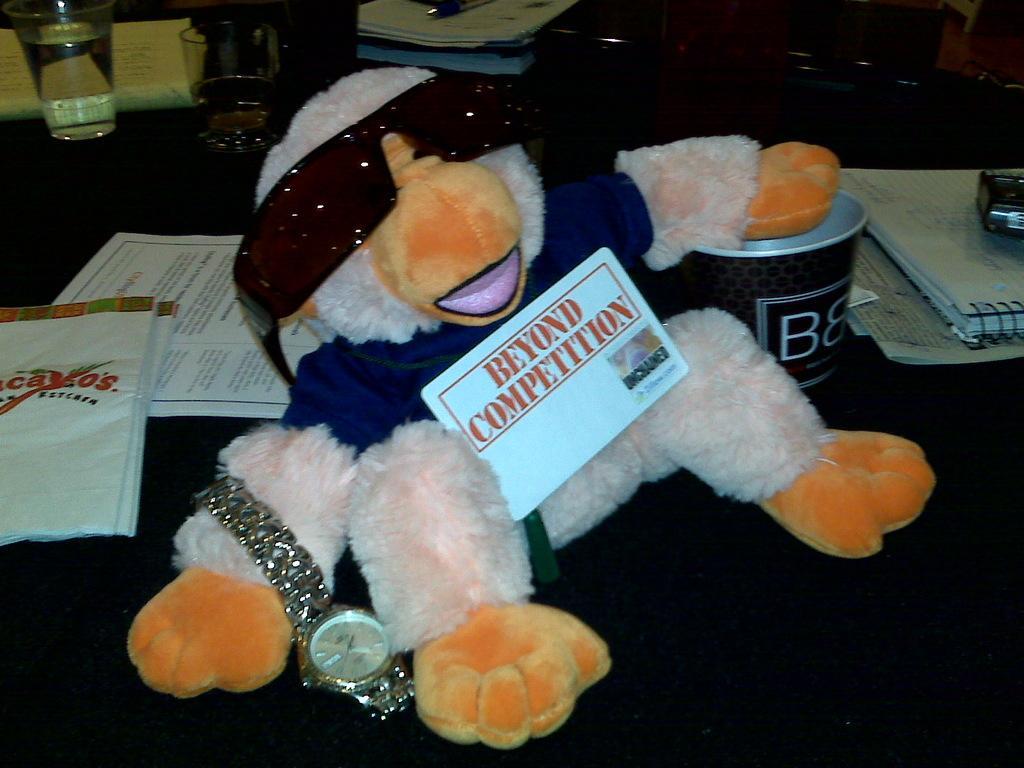Can you describe this image briefly? In this image, there is a toy wearing sunglasses and watch. There is a book and cup on the right side of the image. There are glasses in the top left of the image. There are some papers on the left side of the image. 